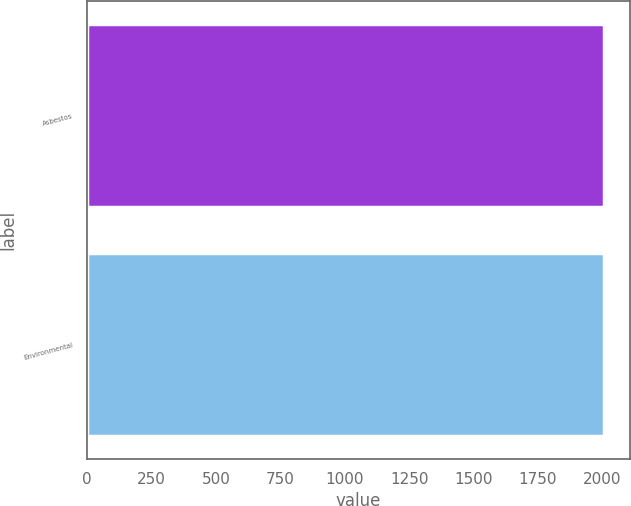<chart> <loc_0><loc_0><loc_500><loc_500><bar_chart><fcel>Asbestos<fcel>Environmental<nl><fcel>2008<fcel>2008.1<nl></chart> 